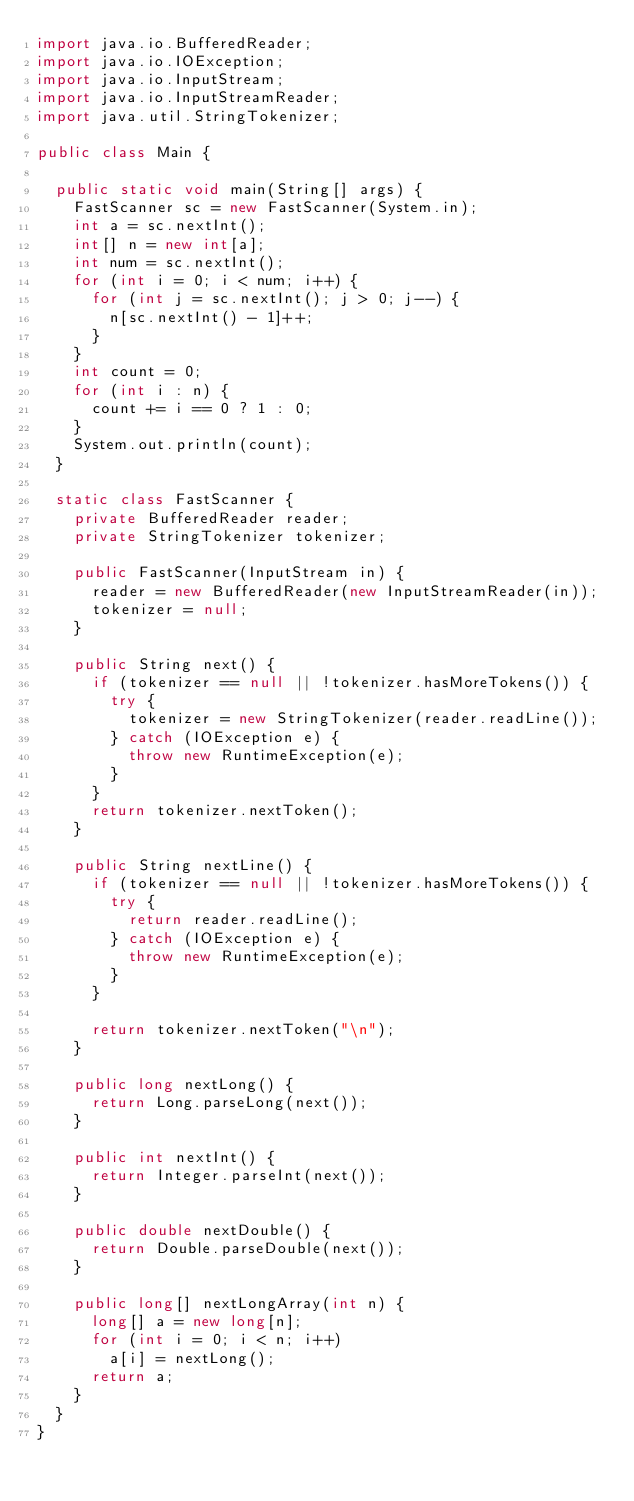Convert code to text. <code><loc_0><loc_0><loc_500><loc_500><_Java_>import java.io.BufferedReader;
import java.io.IOException;
import java.io.InputStream;
import java.io.InputStreamReader;
import java.util.StringTokenizer;

public class Main {

	public static void main(String[] args) {
		FastScanner sc = new FastScanner(System.in);
		int a = sc.nextInt();
		int[] n = new int[a];
		int num = sc.nextInt();
		for (int i = 0; i < num; i++) {
			for (int j = sc.nextInt(); j > 0; j--) {
				n[sc.nextInt() - 1]++;
			}
		}
		int count = 0;
		for (int i : n) {
			count += i == 0 ? 1 : 0;
		}
		System.out.println(count);
	}

	static class FastScanner {
		private BufferedReader reader;
		private StringTokenizer tokenizer;

		public FastScanner(InputStream in) {
			reader = new BufferedReader(new InputStreamReader(in));
			tokenizer = null;
		}

		public String next() {
			if (tokenizer == null || !tokenizer.hasMoreTokens()) {
				try {
					tokenizer = new StringTokenizer(reader.readLine());
				} catch (IOException e) {
					throw new RuntimeException(e);
				}
			}
			return tokenizer.nextToken();
		}

		public String nextLine() {
			if (tokenizer == null || !tokenizer.hasMoreTokens()) {
				try {
					return reader.readLine();
				} catch (IOException e) {
					throw new RuntimeException(e);
				}
			}

			return tokenizer.nextToken("\n");
		}

		public long nextLong() {
			return Long.parseLong(next());
		}

		public int nextInt() {
			return Integer.parseInt(next());
		}

		public double nextDouble() {
			return Double.parseDouble(next());
		}

		public long[] nextLongArray(int n) {
			long[] a = new long[n];
			for (int i = 0; i < n; i++)
				a[i] = nextLong();
			return a;
		}
	}
}</code> 